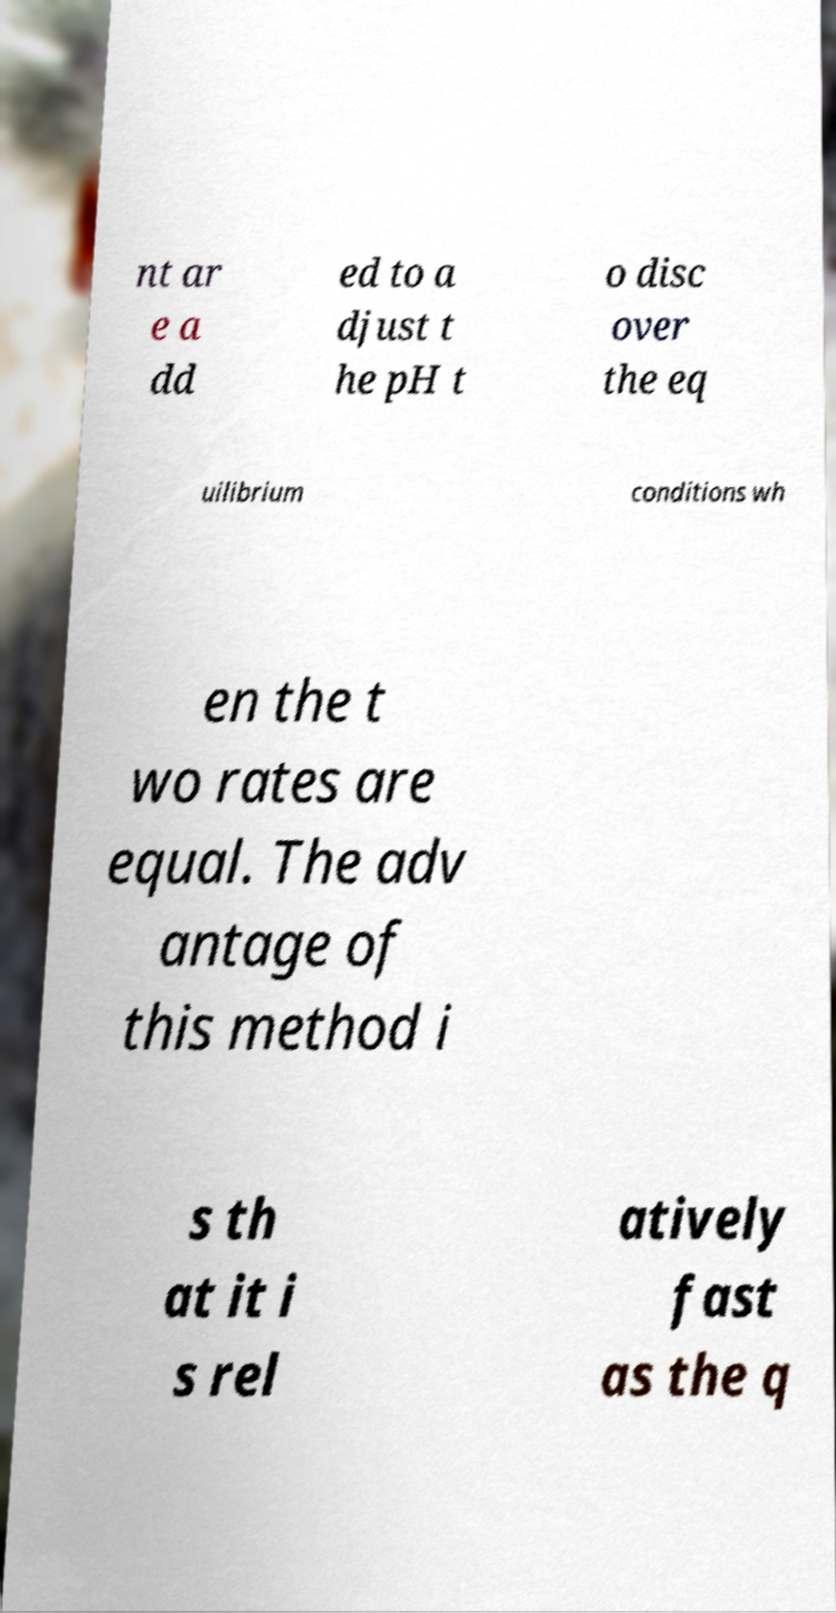Please read and relay the text visible in this image. What does it say? nt ar e a dd ed to a djust t he pH t o disc over the eq uilibrium conditions wh en the t wo rates are equal. The adv antage of this method i s th at it i s rel atively fast as the q 